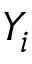Convert formula to latex. <formula><loc_0><loc_0><loc_500><loc_500>Y _ { i }</formula> 